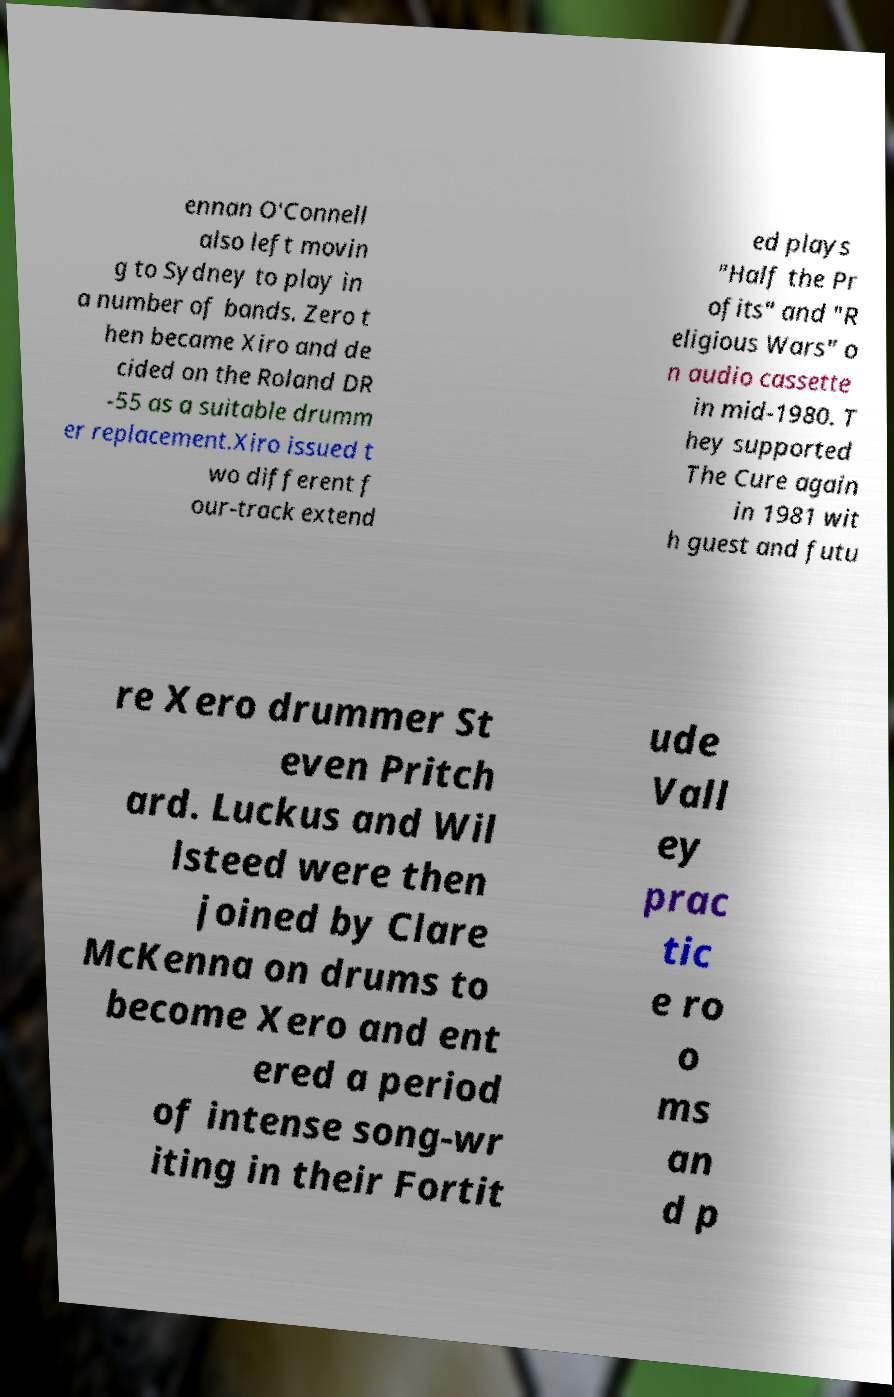Please read and relay the text visible in this image. What does it say? ennan O'Connell also left movin g to Sydney to play in a number of bands. Zero t hen became Xiro and de cided on the Roland DR -55 as a suitable drumm er replacement.Xiro issued t wo different f our-track extend ed plays "Half the Pr ofits" and "R eligious Wars" o n audio cassette in mid-1980. T hey supported The Cure again in 1981 wit h guest and futu re Xero drummer St even Pritch ard. Luckus and Wil lsteed were then joined by Clare McKenna on drums to become Xero and ent ered a period of intense song-wr iting in their Fortit ude Vall ey prac tic e ro o ms an d p 